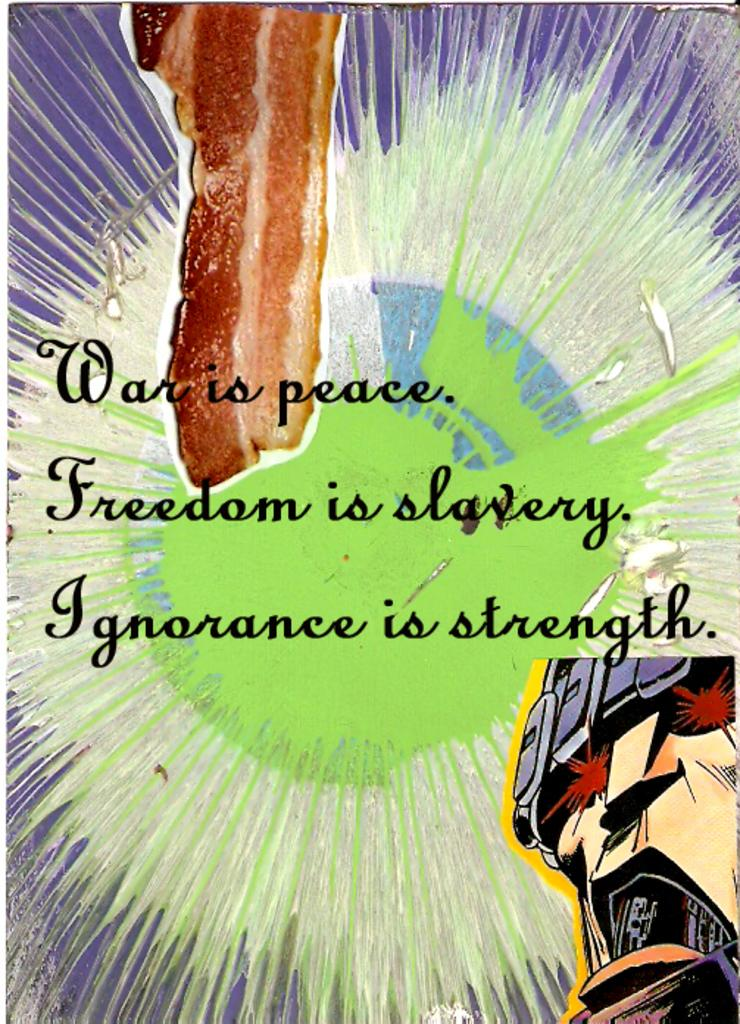Provide a one-sentence caption for the provided image. Colorful background featuring a host of edgy quotes such as "War is peace". 